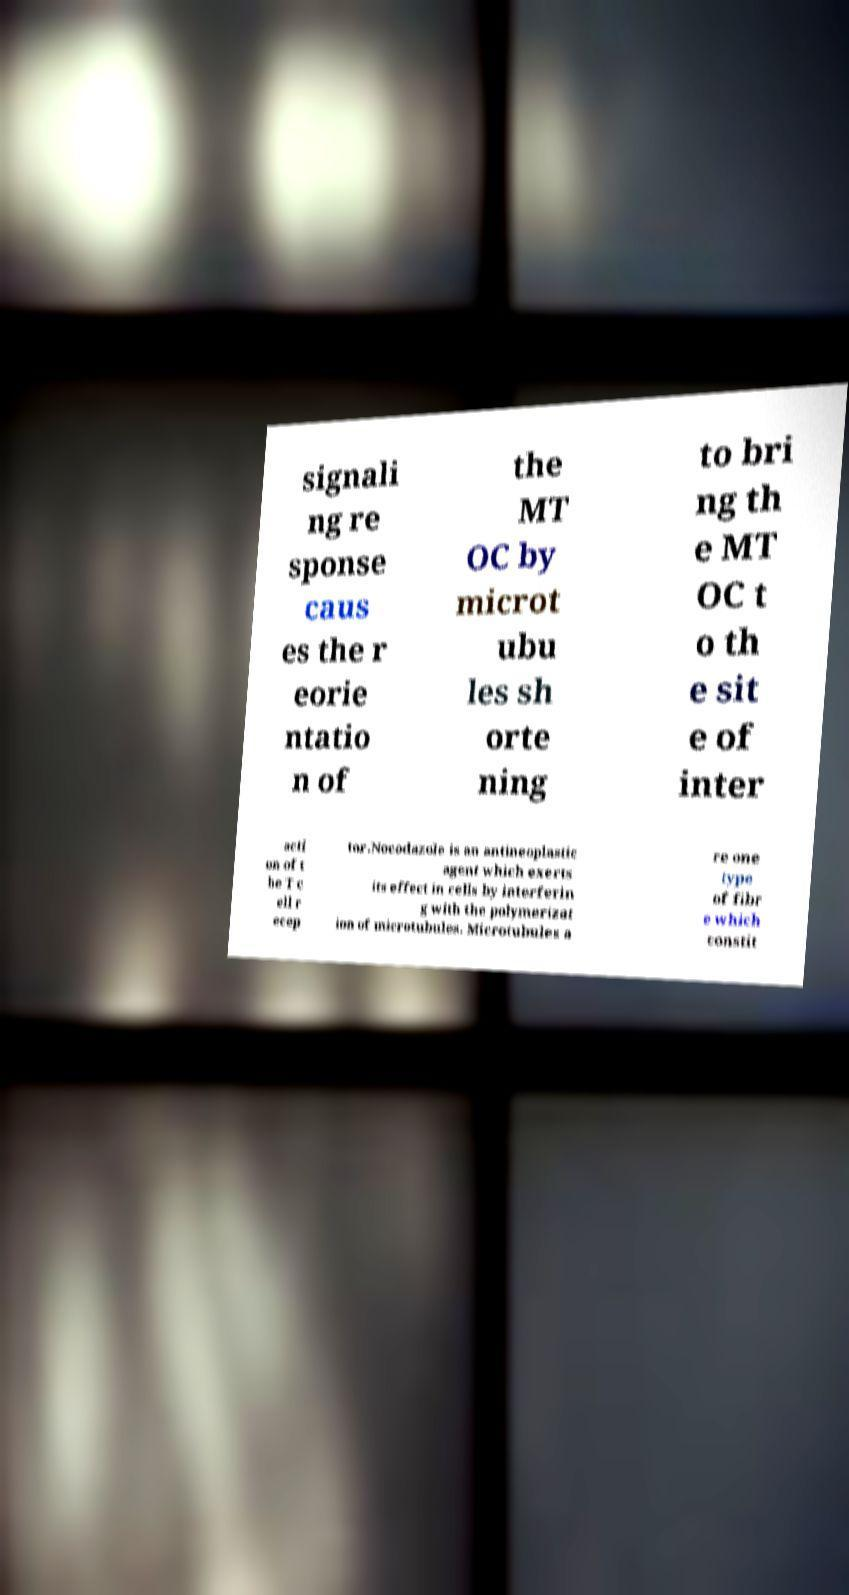Can you accurately transcribe the text from the provided image for me? signali ng re sponse caus es the r eorie ntatio n of the MT OC by microt ubu les sh orte ning to bri ng th e MT OC t o th e sit e of inter acti on of t he T c ell r ecep tor.Nocodazole is an antineoplastic agent which exerts its effect in cells by interferin g with the polymerizat ion of microtubules. Microtubules a re one type of fibr e which constit 